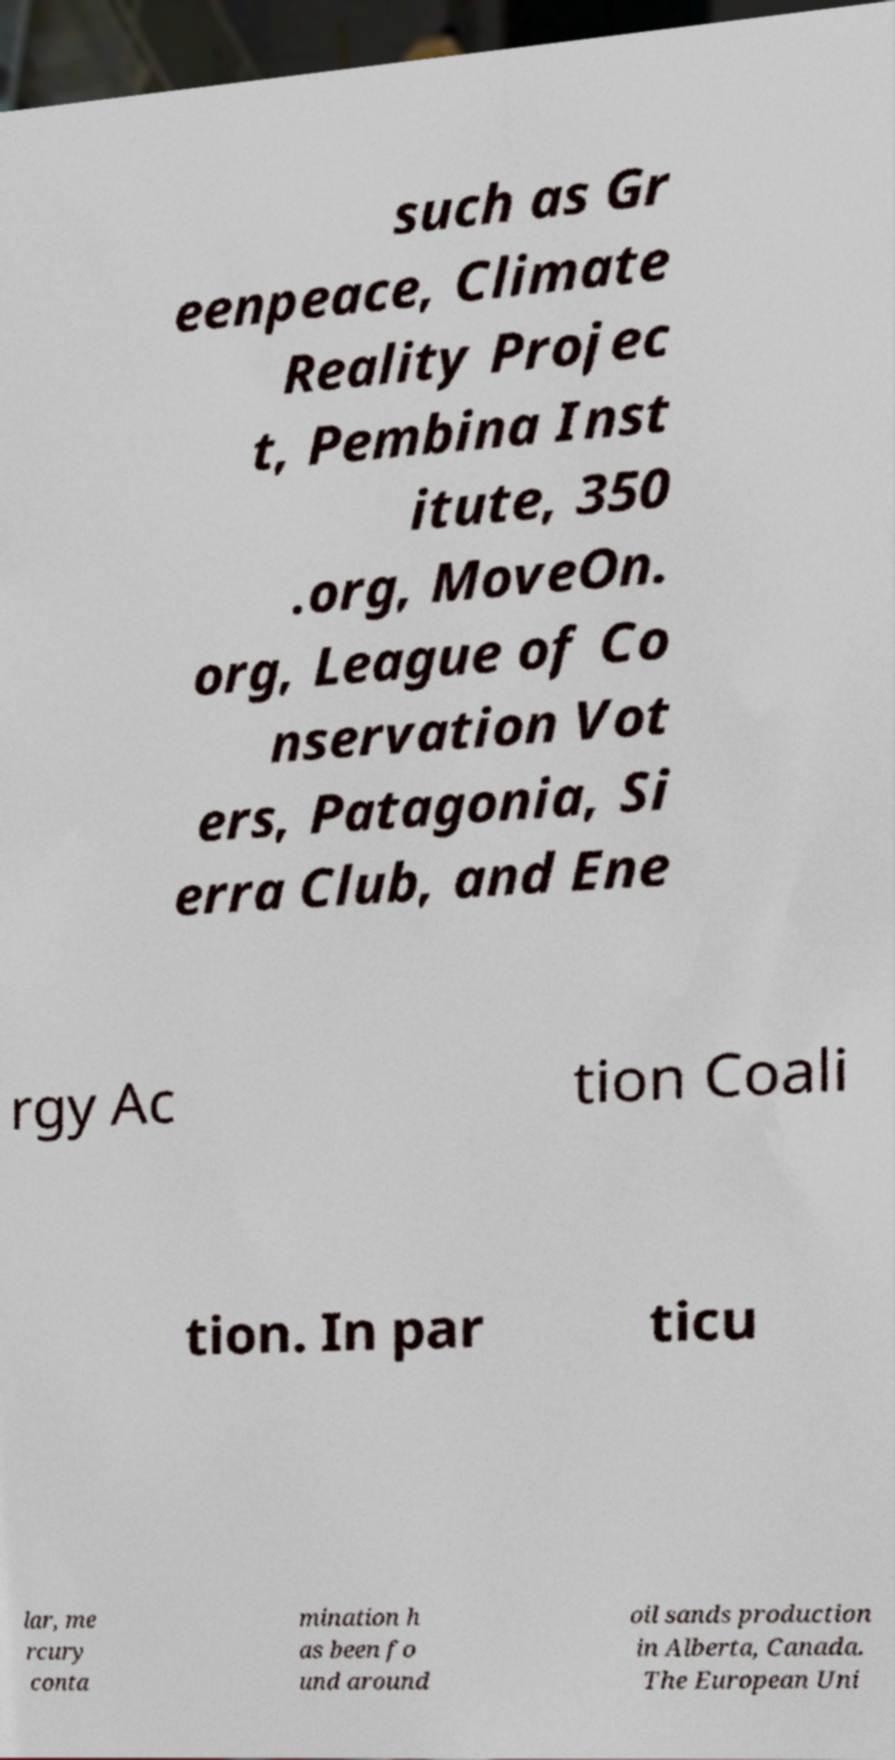For documentation purposes, I need the text within this image transcribed. Could you provide that? such as Gr eenpeace, Climate Reality Projec t, Pembina Inst itute, 350 .org, MoveOn. org, League of Co nservation Vot ers, Patagonia, Si erra Club, and Ene rgy Ac tion Coali tion. In par ticu lar, me rcury conta mination h as been fo und around oil sands production in Alberta, Canada. The European Uni 